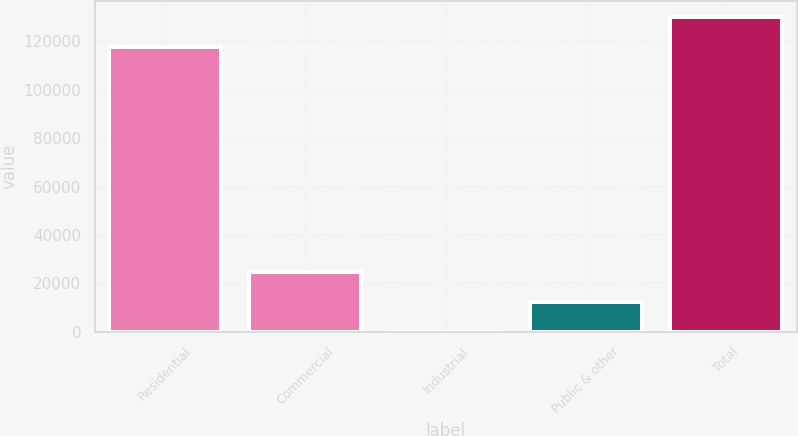Convert chart to OTSL. <chart><loc_0><loc_0><loc_500><loc_500><bar_chart><fcel>Residential<fcel>Commercial<fcel>Industrial<fcel>Public & other<fcel>Total<nl><fcel>117584<fcel>24842<fcel>16<fcel>12429<fcel>129997<nl></chart> 